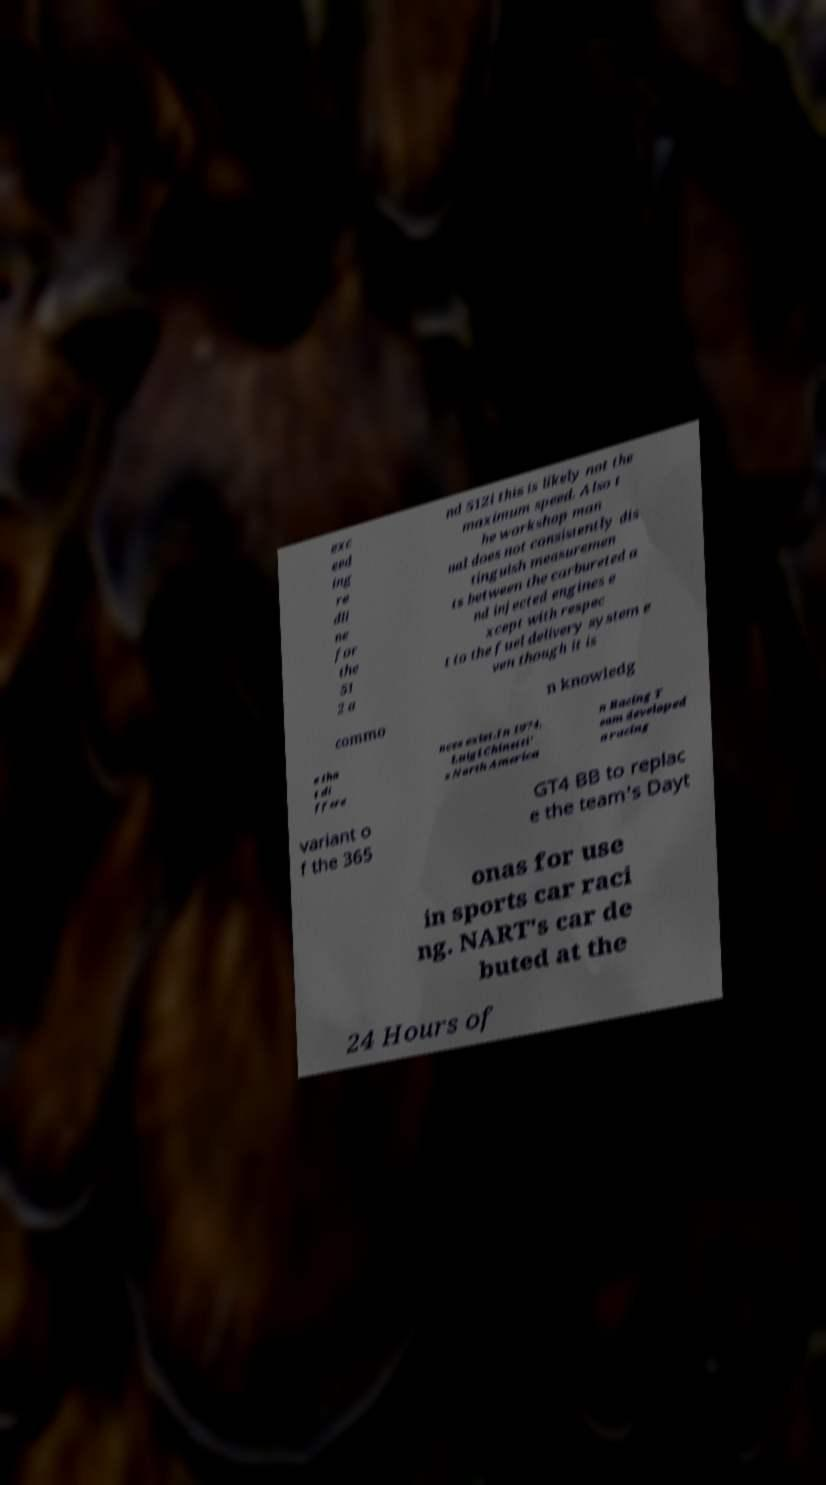Could you assist in decoding the text presented in this image and type it out clearly? exc eed ing re dli ne for the 51 2 a nd 512i this is likely not the maximum speed. Also t he workshop man ual does not consistently dis tinguish measuremen ts between the carbureted a nd injected engines e xcept with respec t to the fuel delivery system e ven though it is commo n knowledg e tha t di ffere nces exist.In 1974, Luigi Chinetti' s North America n Racing T eam developed a racing variant o f the 365 GT4 BB to replac e the team's Dayt onas for use in sports car raci ng. NART's car de buted at the 24 Hours of 